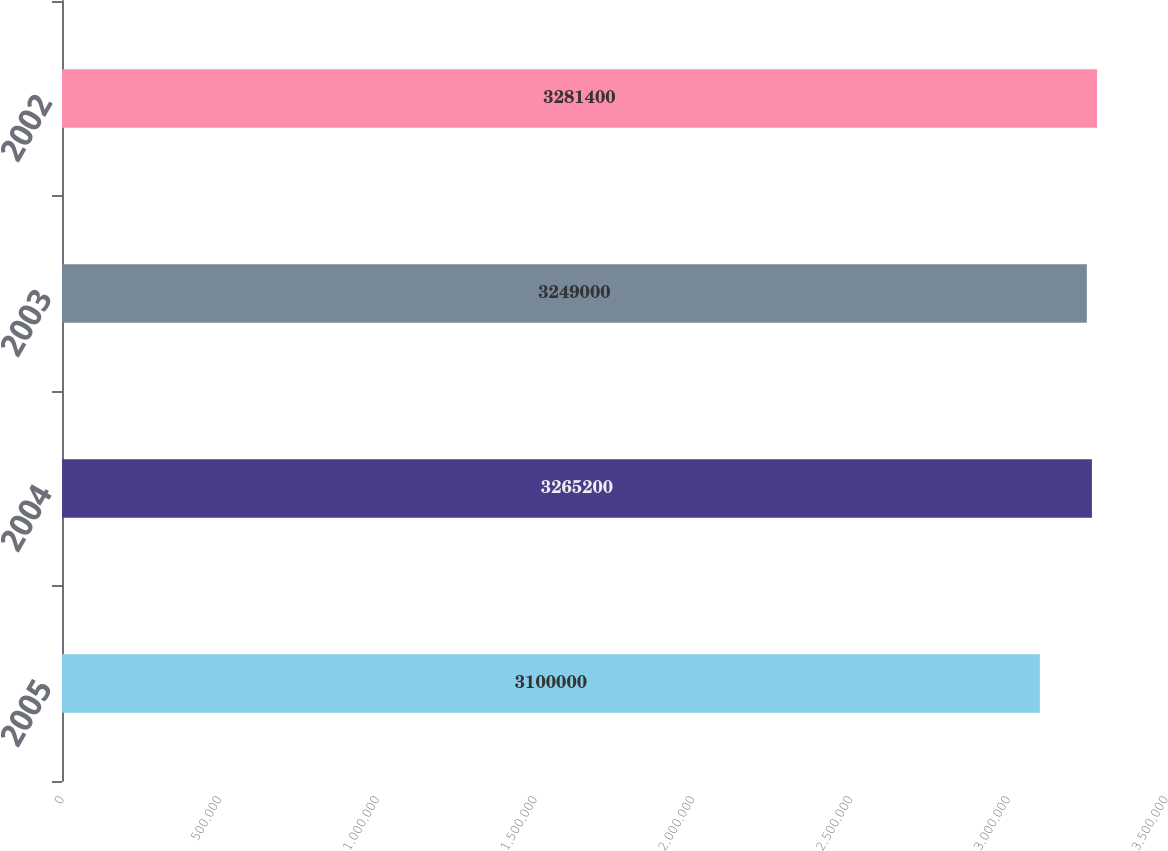<chart> <loc_0><loc_0><loc_500><loc_500><bar_chart><fcel>2005<fcel>2004<fcel>2003<fcel>2002<nl><fcel>3.1e+06<fcel>3.2652e+06<fcel>3.249e+06<fcel>3.2814e+06<nl></chart> 